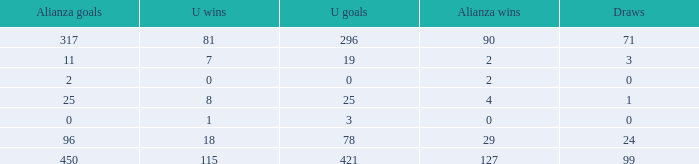What is the total number of U Wins, when Alianza Goals is "0", and when U Goals is greater than 3? 0.0. 